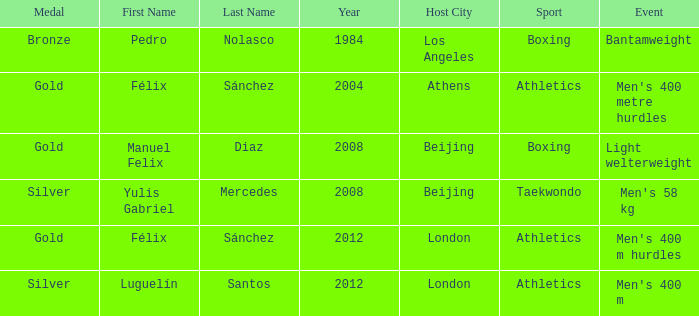Which Name had a Games of 2008 beijing, and a Medal of gold? Manuel Felix Diaz. 